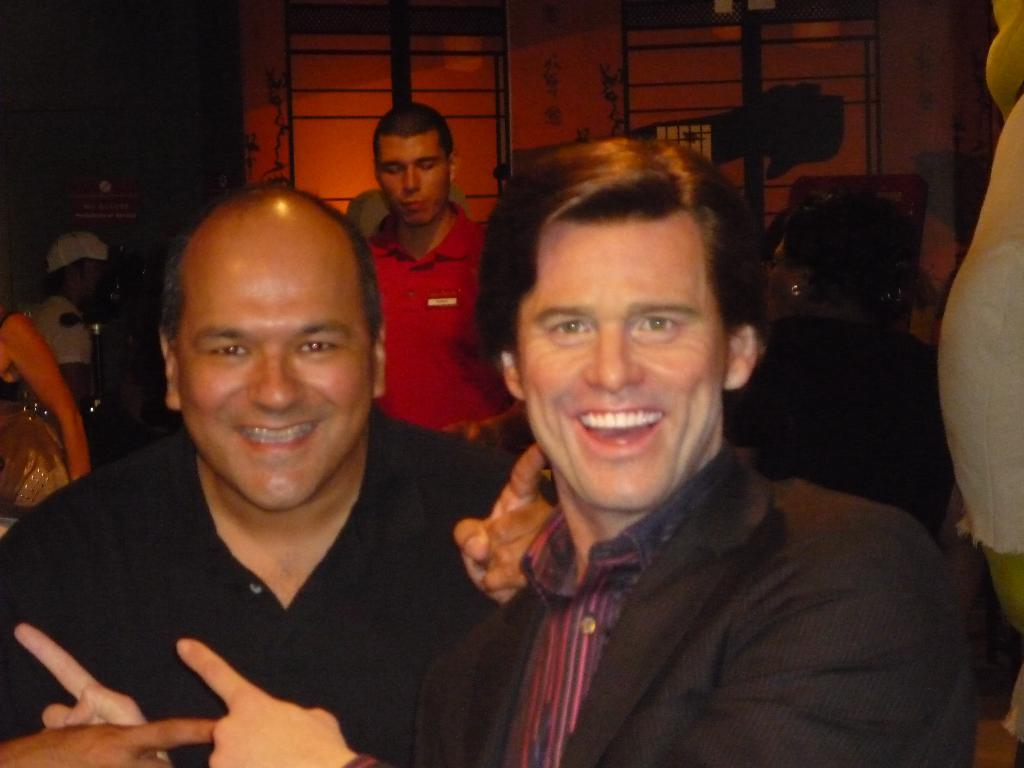How many men are present in the image? There are two men in the image. What is the facial expression of the men? The men are smiling. Can you describe the people in the background of the image? There are other persons in the background of the image. What is the quality of the image? The image is not clear enough to describe the objects in detail. What language are the men speaking in the image? The image does not provide any audio or textual information about the language being spoken. How much did the men pay for the items in the image? There is no indication of any transaction or payment in the image. 